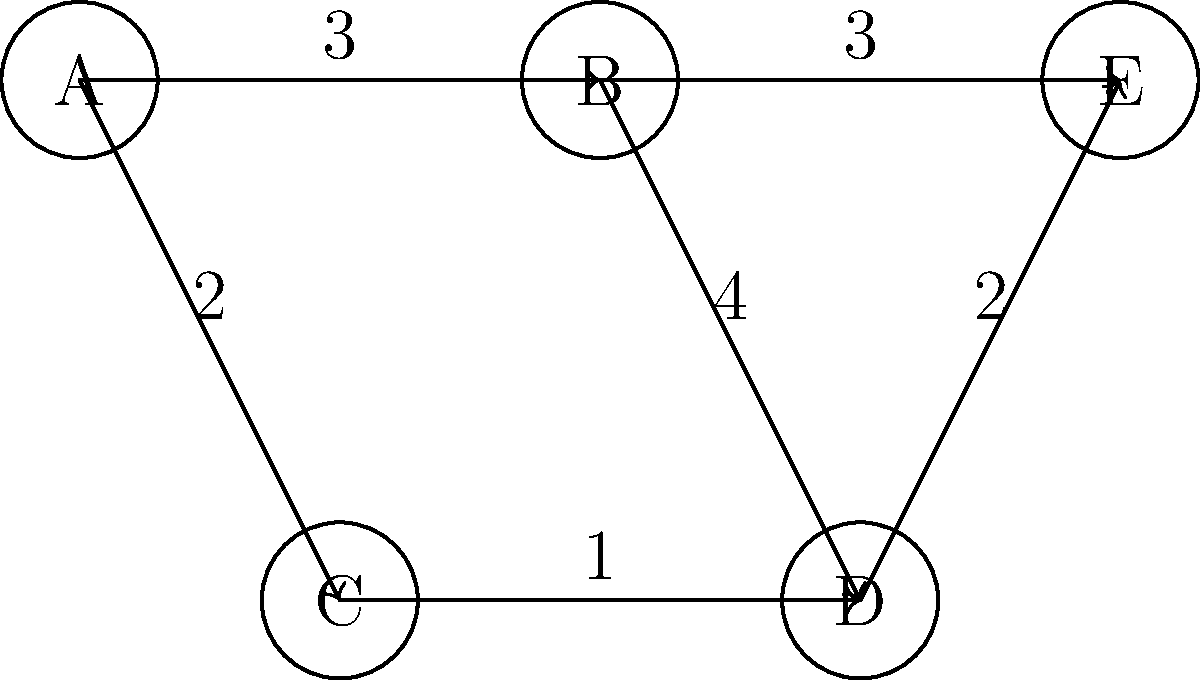In the context of a TFS API project, you're implementing a feature to find the shortest path between two work items. This can be modeled as a directed graph problem. Given the directed graph above, where nodes represent work items and edge weights represent the effort required to transition between items, what is the shortest path from node A to node E, and what is its total weight? To find the shortest path from A to E, we'll use Dijkstra's algorithm, which is commonly used for finding the shortest path in weighted graphs. Here's a step-by-step explanation:

1. Initialize distances: 
   A: 0 (start node)
   B, C, D, E: ∞ (infinity)

2. Visit node A:
   - Update B: min(∞, 0 + 3) = 3
   - Update C: min(∞, 0 + 2) = 2

3. Visit node C (smallest unvisited distance):
   - Update D: min(∞, 2 + 1) = 3

4. Visit node B (next smallest unvisited distance):
   - D is already 3, no update needed
   - Update E: min(∞, 3 + 3) = 6

5. Visit node D:
   - Update E: min(6, 3 + 2) = 5

6. Visit node E (destination reached)

The shortest path is A → C → D → E with a total weight of:
$$(2 + 1 + 2) = 5$$

This approach can be implemented using the TFS API to traverse work item relationships and calculate the most efficient path between two items based on custom criteria or effort estimations.
Answer: A → C → D → E, weight: 5 